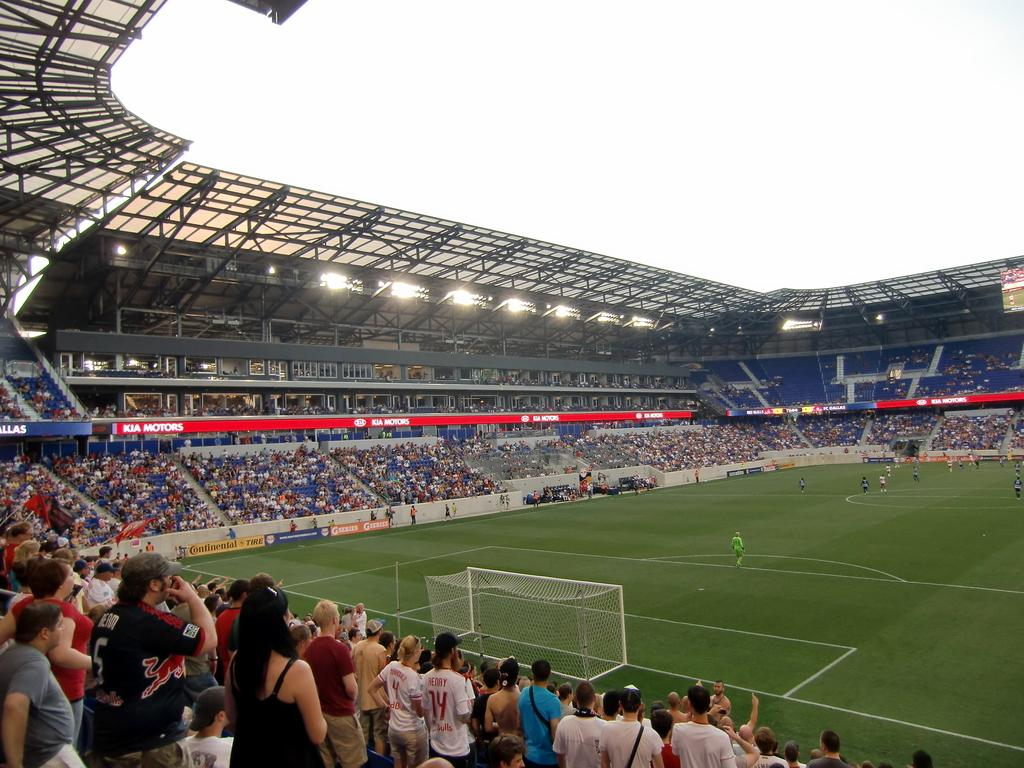<image>
Provide a brief description of the given image. A stadium full of people looking out onto the field with Kia Motors being advertized around stadium. 